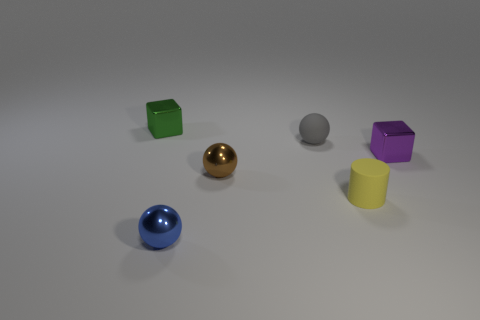Subtract all brown balls. How many balls are left? 2 Subtract all blue spheres. How many spheres are left? 2 Add 3 tiny blocks. How many objects exist? 9 Subtract all blocks. How many objects are left? 4 Subtract all red cubes. Subtract all brown balls. How many cubes are left? 2 Subtract 0 blue cubes. How many objects are left? 6 Subtract 2 blocks. How many blocks are left? 0 Subtract all yellow cubes. How many brown spheres are left? 1 Subtract all green things. Subtract all green cubes. How many objects are left? 4 Add 3 small rubber things. How many small rubber things are left? 5 